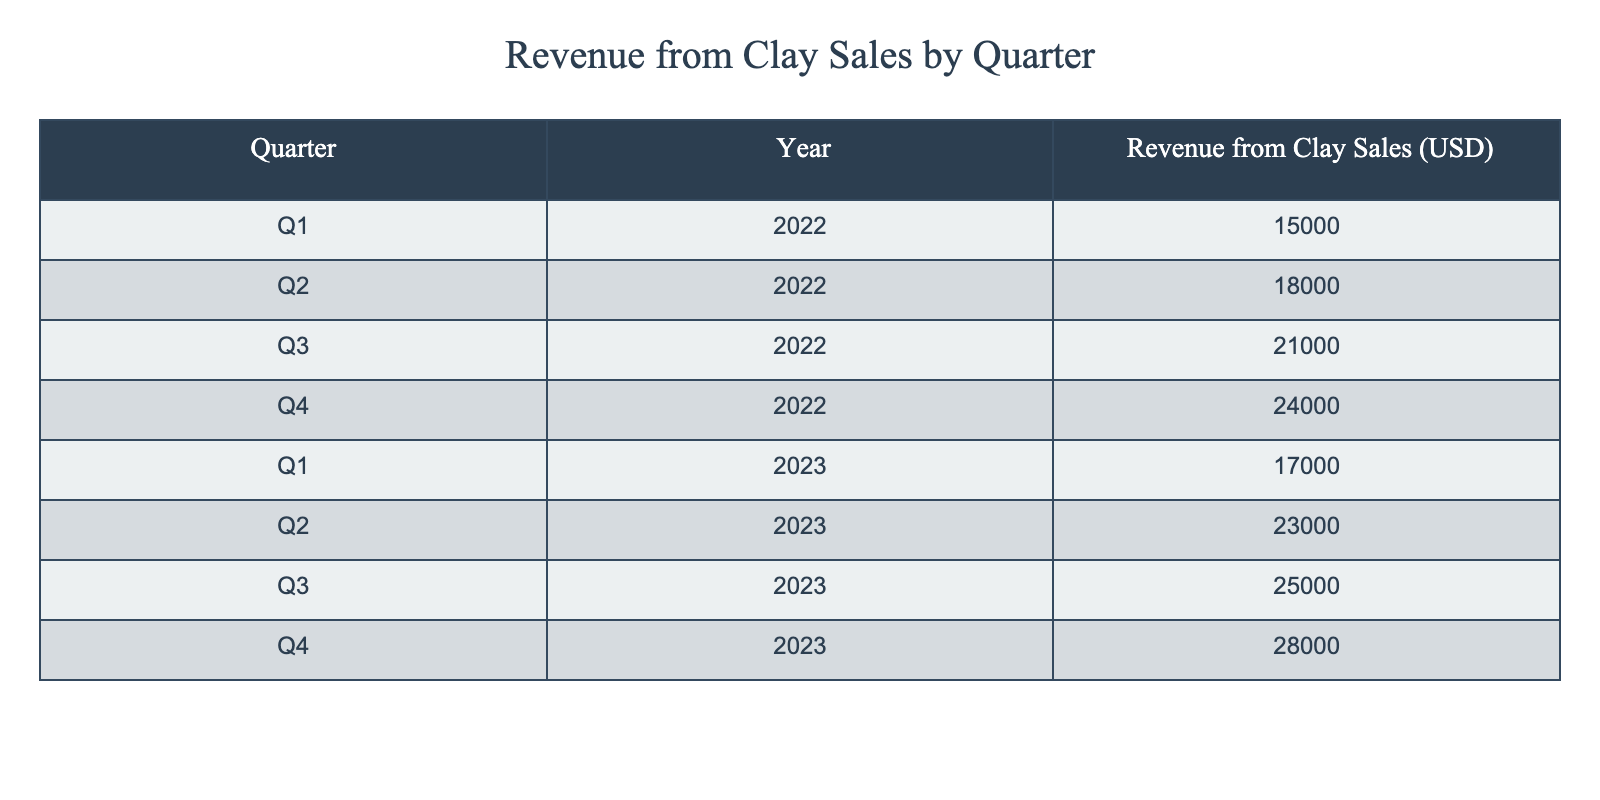What was the revenue from clay sales in Q3 of 2022? The table indicates that the revenue from clay sales in Q3 of 2022 is directly listed under that quarter and year, which is 21,000 USD.
Answer: 21,000 USD What was the highest revenue generated in a single quarter over the two years? The table lists the revenues for each quarter. The highest figure is found in Q4 of 2023, which shows a revenue of 28,000 USD.
Answer: 28,000 USD What is the total revenue from clay sales for the year 2023? To find this, we must sum the revenues from all four quarters of 2023: (17,000 + 23,000 + 25,000 + 28,000). This equals 93,000 USD.
Answer: 93,000 USD Is the revenue from clay sales in Q2 of 2023 greater than the average revenue from all quarters of 2022? First, the average revenue for 2022 is calculated by summing the revenues for all quarters of that year: (15,000 + 18,000 + 21,000 + 24,000) = 78,000 USD. Then divide by 4, which gives 19,500 USD. Now compare Q2 of 2023 at 23,000 USD, which is greater than 19,500 USD.
Answer: Yes What is the percentage increase in revenue from Q1 2022 to Q1 2023? First, we identify the revenue values: Q1 2022 is 15,000 USD, and Q1 2023 is 17,000 USD. The difference is(17,000 - 15,000) = 2,000 USD. To find the percentage increase, divide the difference by the original value: (2,000 / 15,000) * 100 = 13.33%.
Answer: 13.33% What was the total revenue from clay sales in 2022 compared to 2023? Sum the revenues for 2022: (15,000 + 18,000 + 21,000 + 24,000) = 78,000 USD and for 2023: (17,000 + 23,000 + 25,000 + 28,000) = 93,000 USD. Comparing these totals shows 93,000 is greater than 78,000.
Answer: 2023 is greater Was there a decline in revenue from any quarter to the next during 2022? Looking at the revenue figures in 2022: Q1 to Q2 shows an increase (15,000 to 18,000), Q2 to Q3 shows an increase (18,000 to 21,000), and Q3 to Q4 shows an increase (21,000 to 24,000). Therefore, there were no declines in revenue during 2022.
Answer: No How much more revenue did clay sales generate in Q4 2023 compared to Q3 2023? The revenue for Q4 2023 is 28,000 USD and for Q3 2023 is 25,000 USD. The difference is (28,000 - 25,000) = 3,000 USD.
Answer: 3,000 USD 